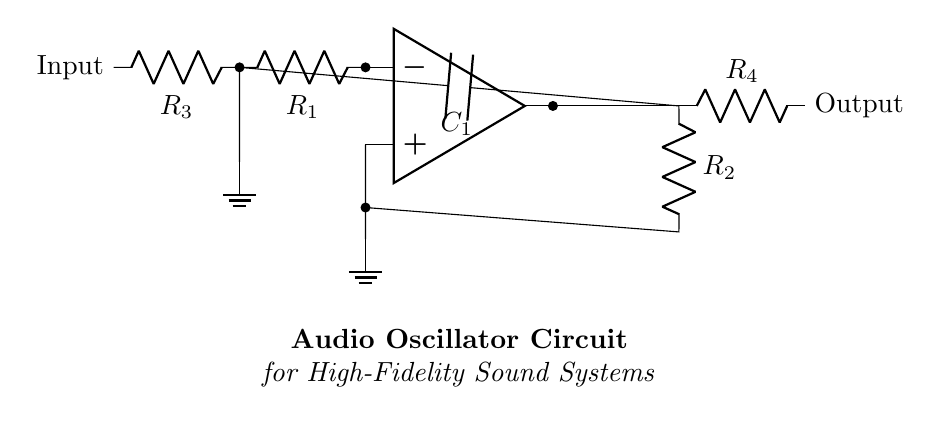What type of components are present in this circuit? The circuit shows resistors, capacitors, and an operational amplifier. These elements are commonly used in audio oscillator circuits for signal processing.
Answer: resistors, capacitors, operational amplifier What is the purpose of the resistor labeled R1? R1 is connected to the input and serves as a feedback resistor in the operational amplifier setup, which is crucial for determining gain and stability.
Answer: feedback resistor What does the capacitor C1 do in the circuit? C1 is positioned in the feedback loop and helps in setting the frequency of oscillation, smoothing the output waveform for high-fidelity sound.
Answer: sets frequency How many resistors are in this circuit? There are four resistors in total, denoted as R1, R2, R3, and R4. Counting all resistors gives a total of four.
Answer: four What is the output configuration of the amplifier? The output is taken as a voltage across resistor R4, which indicates that it is configured to produce a voltage signal as the output of the oscillator circuit.
Answer: voltage signal Why is R2 connected to the output and ground? R2 works as a pull-down resistor in the feedback path, which stabilizes the output voltage at the reference ground level, facilitating a consistent oscillator output.
Answer: stabilizes output What type of circuit is this? This is classified as an audio oscillator circuit designed for generating sound waves, mainly used in high-fidelity sound systems.
Answer: audio oscillator 